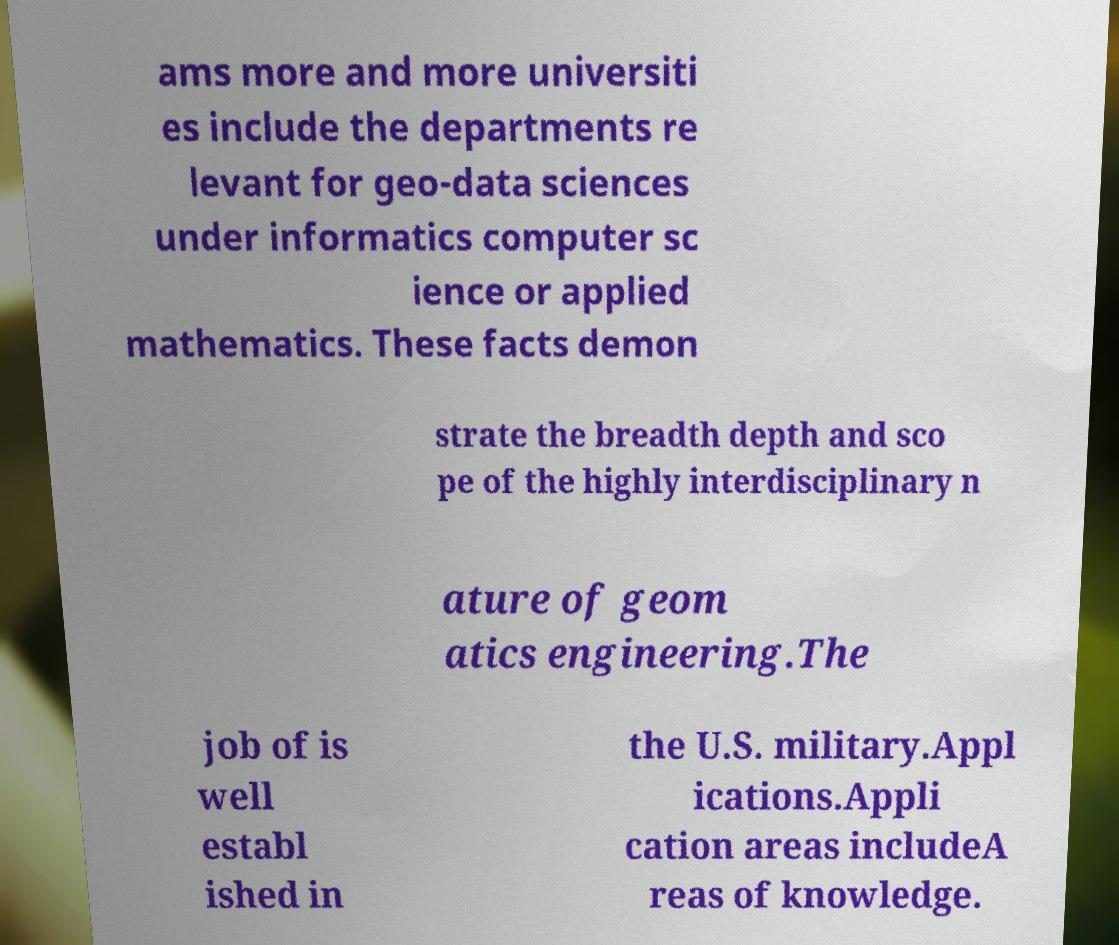There's text embedded in this image that I need extracted. Can you transcribe it verbatim? ams more and more universiti es include the departments re levant for geo-data sciences under informatics computer sc ience or applied mathematics. These facts demon strate the breadth depth and sco pe of the highly interdisciplinary n ature of geom atics engineering.The job of is well establ ished in the U.S. military.Appl ications.Appli cation areas includeA reas of knowledge. 